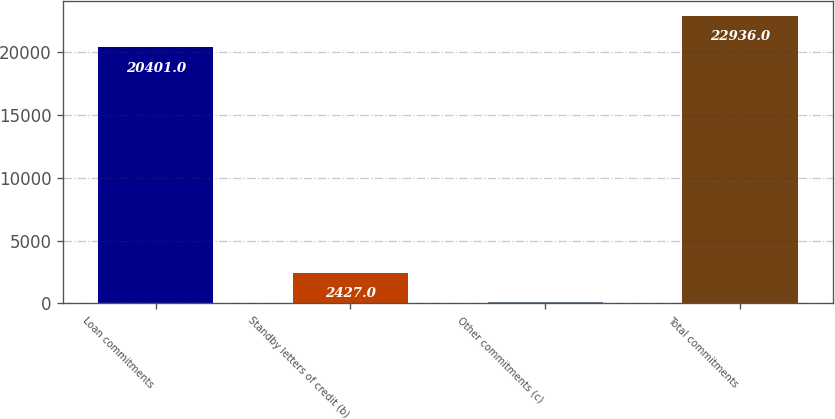Convert chart. <chart><loc_0><loc_0><loc_500><loc_500><bar_chart><fcel>Loan commitments<fcel>Standby letters of credit (b)<fcel>Other commitments (c)<fcel>Total commitments<nl><fcel>20401<fcel>2427<fcel>108<fcel>22936<nl></chart> 